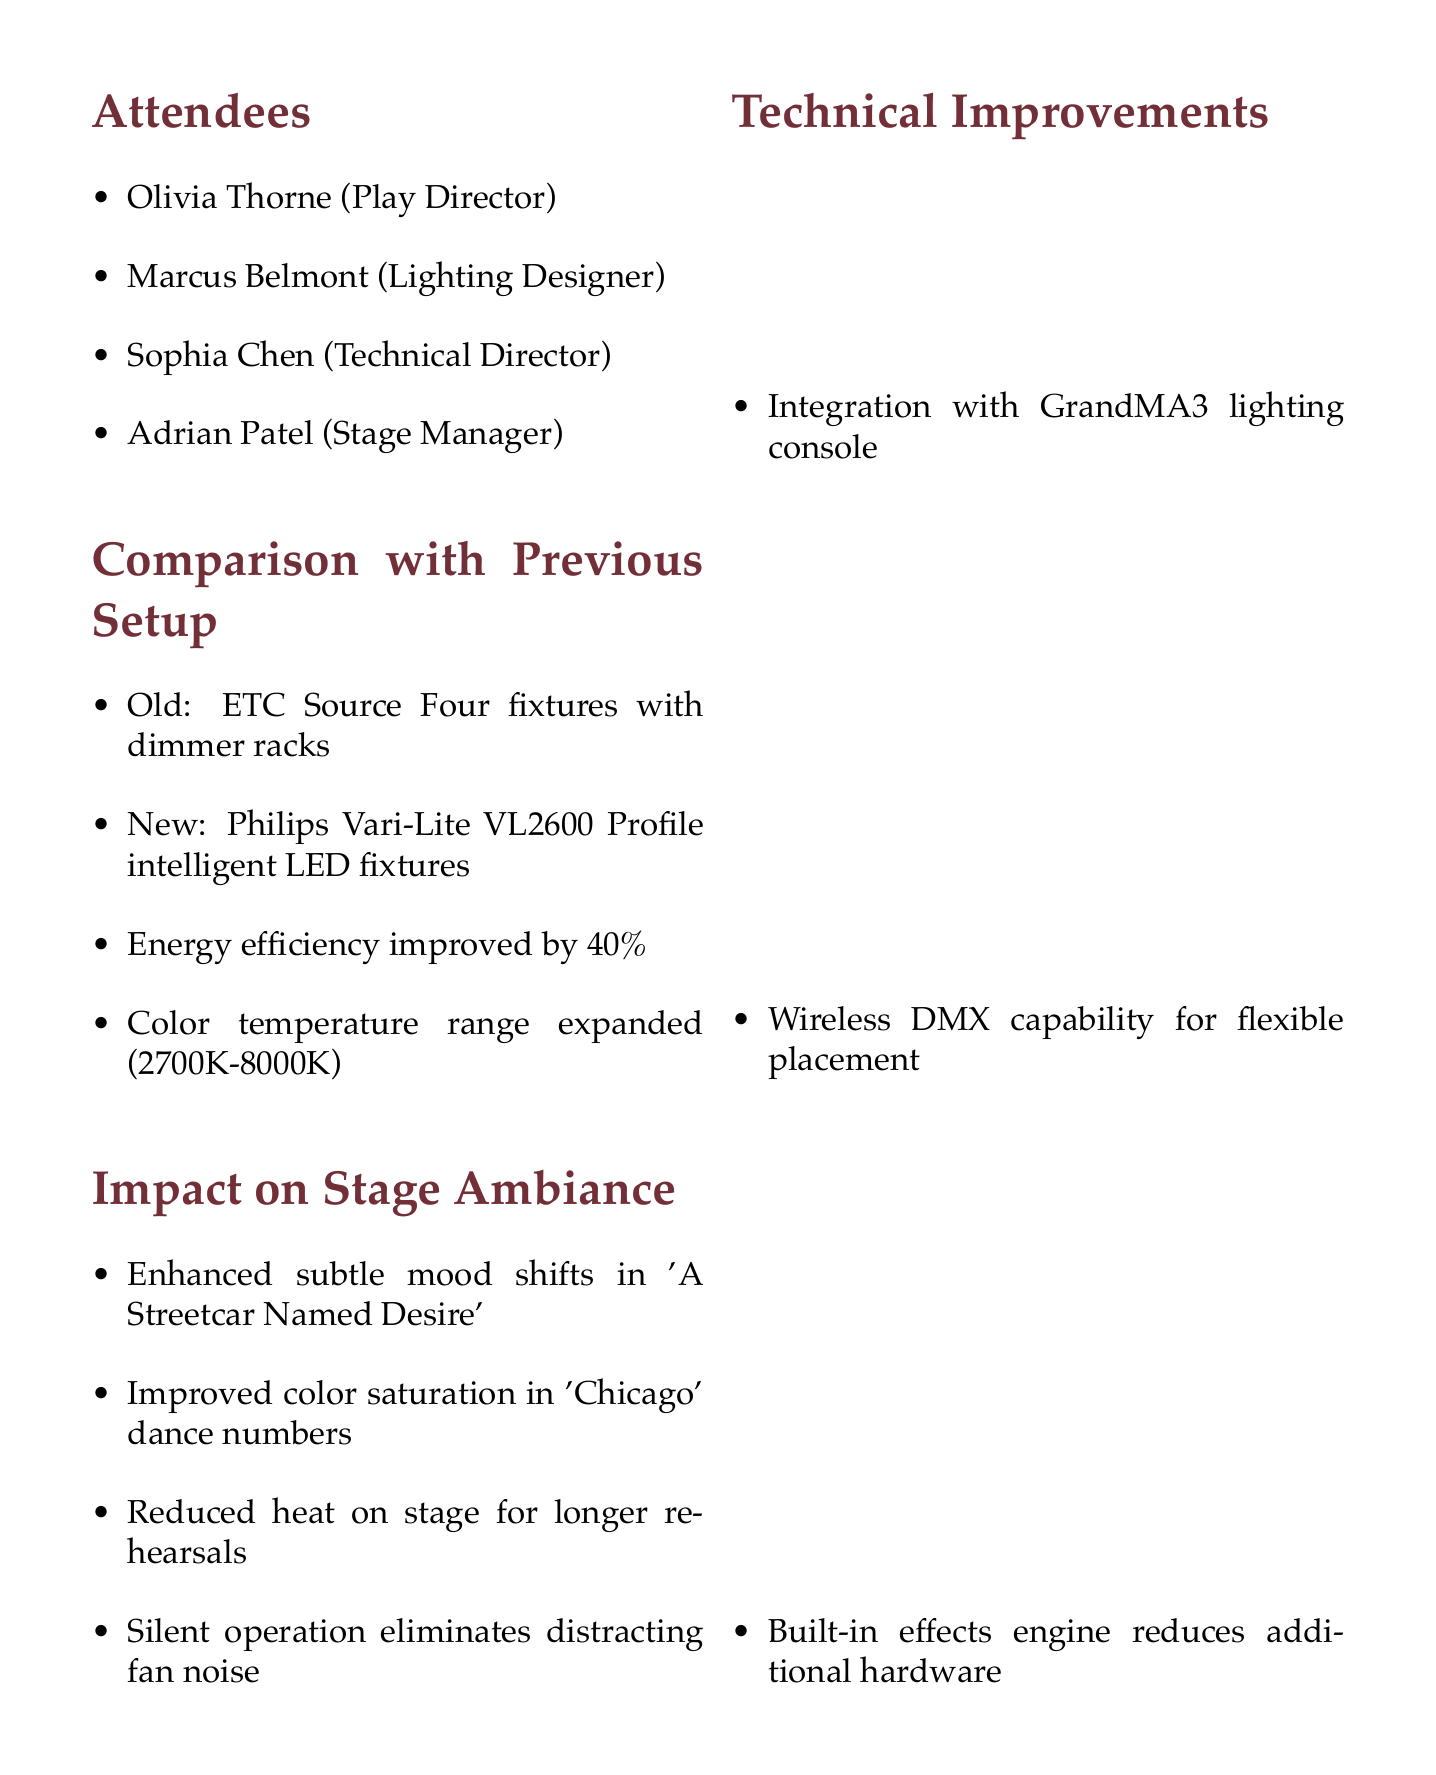What is the date of the meeting? The date of the meeting is explicitly stated at the top of the document as May 15, 2023.
Answer: May 15, 2023 Who is the Lighting Designer? The name of the Lighting Designer is listed among the attendees in the document.
Answer: Marcus Belmont What is the energy efficiency improvement percentage? The document specifies that energy efficiency improved by 40%.
Answer: 40% What production benefited from enhanced subtle mood shifts? The document indicates that 'A Streetcar Named Desire' experienced enhanced subtle mood shifts due to the new lighting system.
Answer: A Streetcar Named Desire What is the initial investment for the new lighting system? The initial investment amount is given in the Cost and ROI Analysis section of the document.
Answer: $75,000 What feature reduces the reliance on additional hardware? The document refers to the built-in effects engine as the feature that reduces reliance on additional hardware.
Answer: Built-in effects engine What is the projected annual energy savings? The document projects the annual energy savings from the new lighting system, listed in the Cost and ROI Analysis section.
Answer: $12,000 What action item is assigned to Sophia? The action items section highlights specific tasks assigned to each attendee, including what Sophia is responsible for.
Answer: Create maintenance schedule What wine pairing is recommended to celebrate the installation? The document concludes with a suggested wine pairing for the occasion, specifically listing the wine and its origin.
Answer: 2018 Château Margaux, Bordeaux 